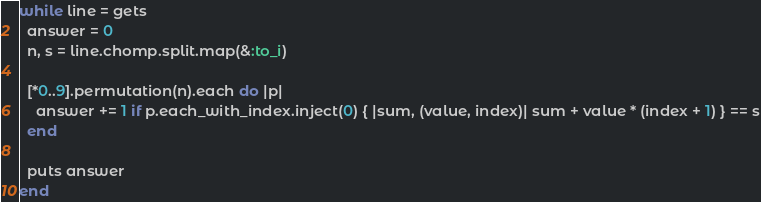Convert code to text. <code><loc_0><loc_0><loc_500><loc_500><_Ruby_>while line = gets
  answer = 0
  n, s = line.chomp.split.map(&:to_i)

  [*0..9].permutation(n).each do |p|
    answer += 1 if p.each_with_index.inject(0) { |sum, (value, index)| sum + value * (index + 1) } == s
  end

  puts answer
end</code> 